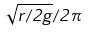<formula> <loc_0><loc_0><loc_500><loc_500>\sqrt { r / 2 g } / 2 \pi</formula> 